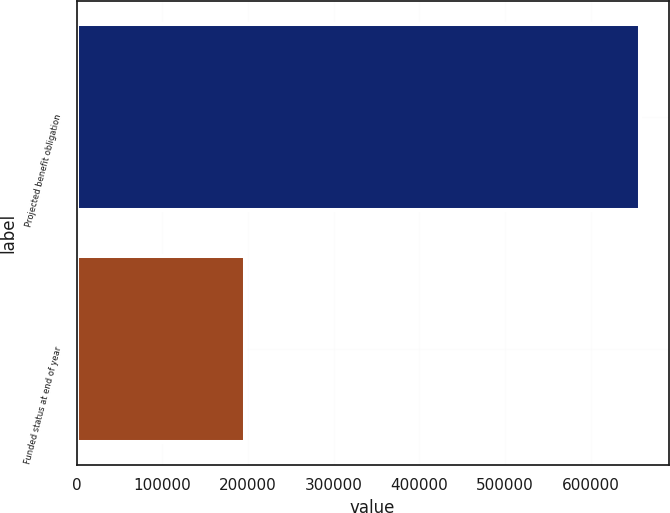Convert chart to OTSL. <chart><loc_0><loc_0><loc_500><loc_500><bar_chart><fcel>Projected benefit obligation<fcel>Funded status at end of year<nl><fcel>658164<fcel>197203<nl></chart> 